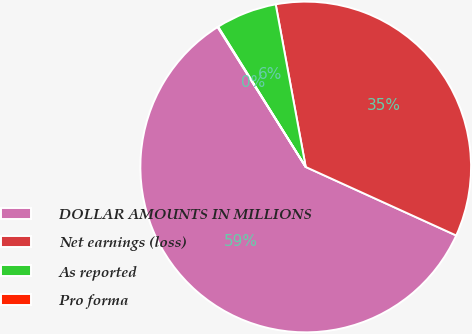<chart> <loc_0><loc_0><loc_500><loc_500><pie_chart><fcel>DOLLAR AMOUNTS IN MILLIONS<fcel>Net earnings (loss)<fcel>As reported<fcel>Pro forma<nl><fcel>59.25%<fcel>34.7%<fcel>5.98%<fcel>0.06%<nl></chart> 